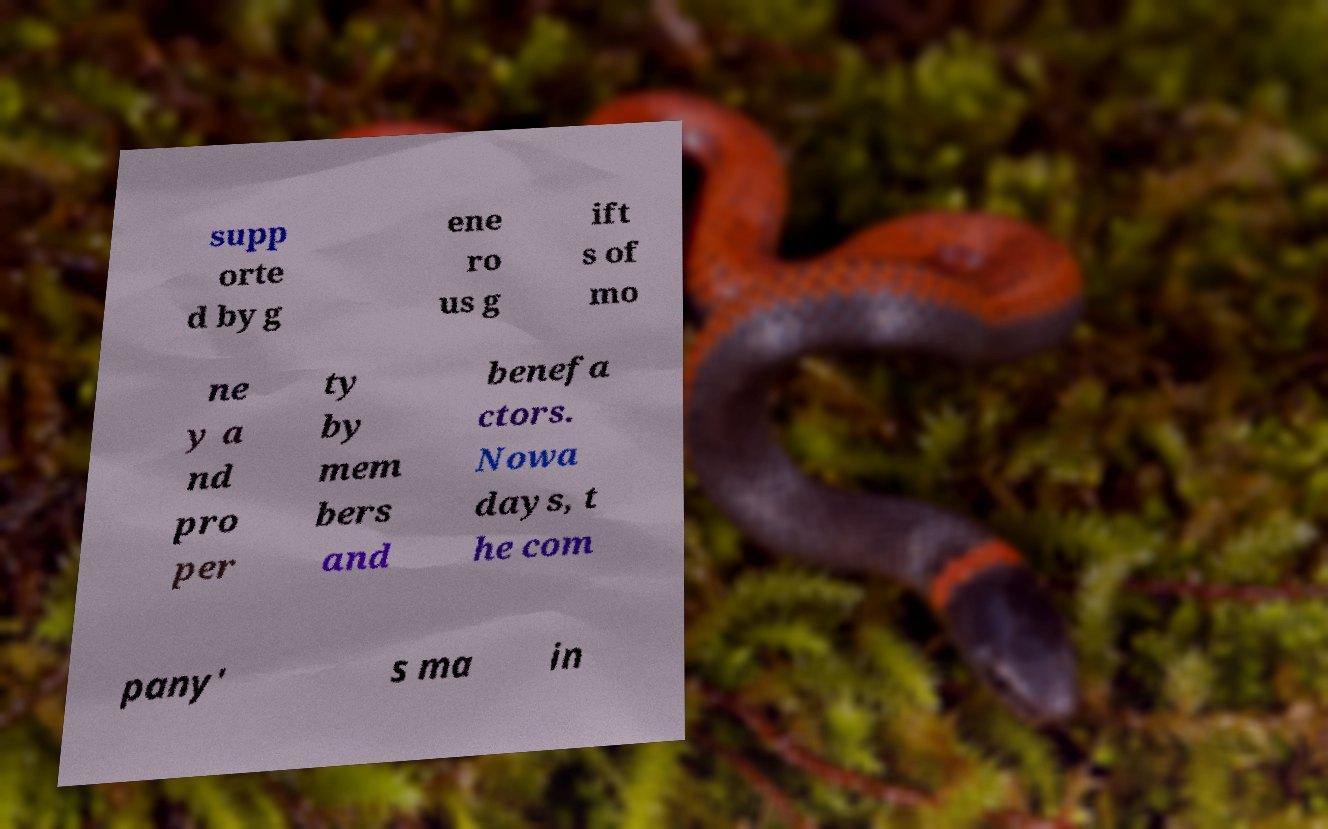Please identify and transcribe the text found in this image. supp orte d by g ene ro us g ift s of mo ne y a nd pro per ty by mem bers and benefa ctors. Nowa days, t he com pany' s ma in 